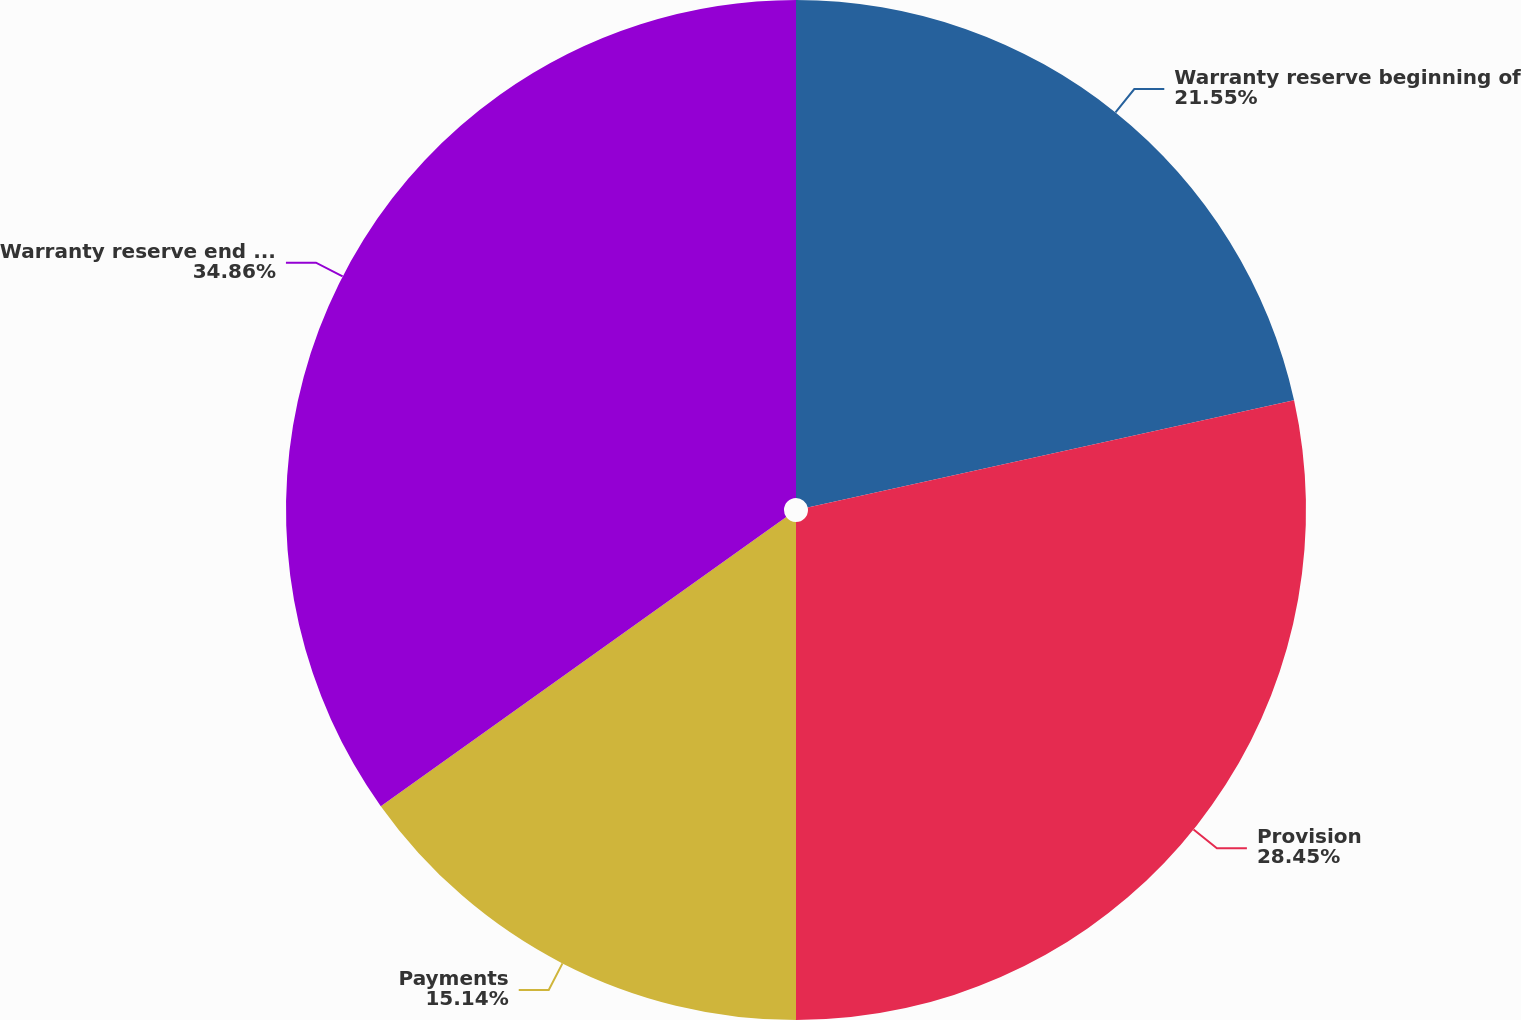Convert chart to OTSL. <chart><loc_0><loc_0><loc_500><loc_500><pie_chart><fcel>Warranty reserve beginning of<fcel>Provision<fcel>Payments<fcel>Warranty reserve end of year<nl><fcel>21.55%<fcel>28.45%<fcel>15.14%<fcel>34.86%<nl></chart> 